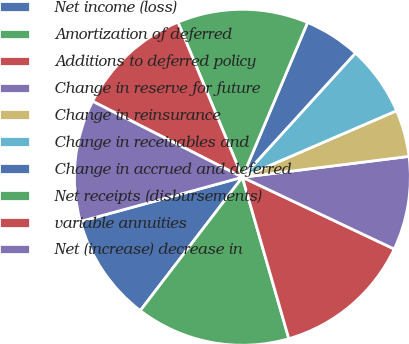<chart> <loc_0><loc_0><loc_500><loc_500><pie_chart><fcel>Net income (loss)<fcel>Amortization of deferred<fcel>Additions to deferred policy<fcel>Change in reserve for future<fcel>Change in reinsurance<fcel>Change in receivables and<fcel>Change in accrued and deferred<fcel>Net receipts (disbursements)<fcel>variable annuities<fcel>Net (increase) decrease in<nl><fcel>10.36%<fcel>14.86%<fcel>13.51%<fcel>9.01%<fcel>4.5%<fcel>6.76%<fcel>5.41%<fcel>12.61%<fcel>11.26%<fcel>11.71%<nl></chart> 